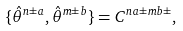<formula> <loc_0><loc_0><loc_500><loc_500>\{ \hat { \theta } ^ { n \pm a } , \hat { \theta } ^ { m \pm b } \} = C ^ { n a \pm m b \pm } ,</formula> 